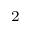<formula> <loc_0><loc_0><loc_500><loc_500>_ { 2 }</formula> 